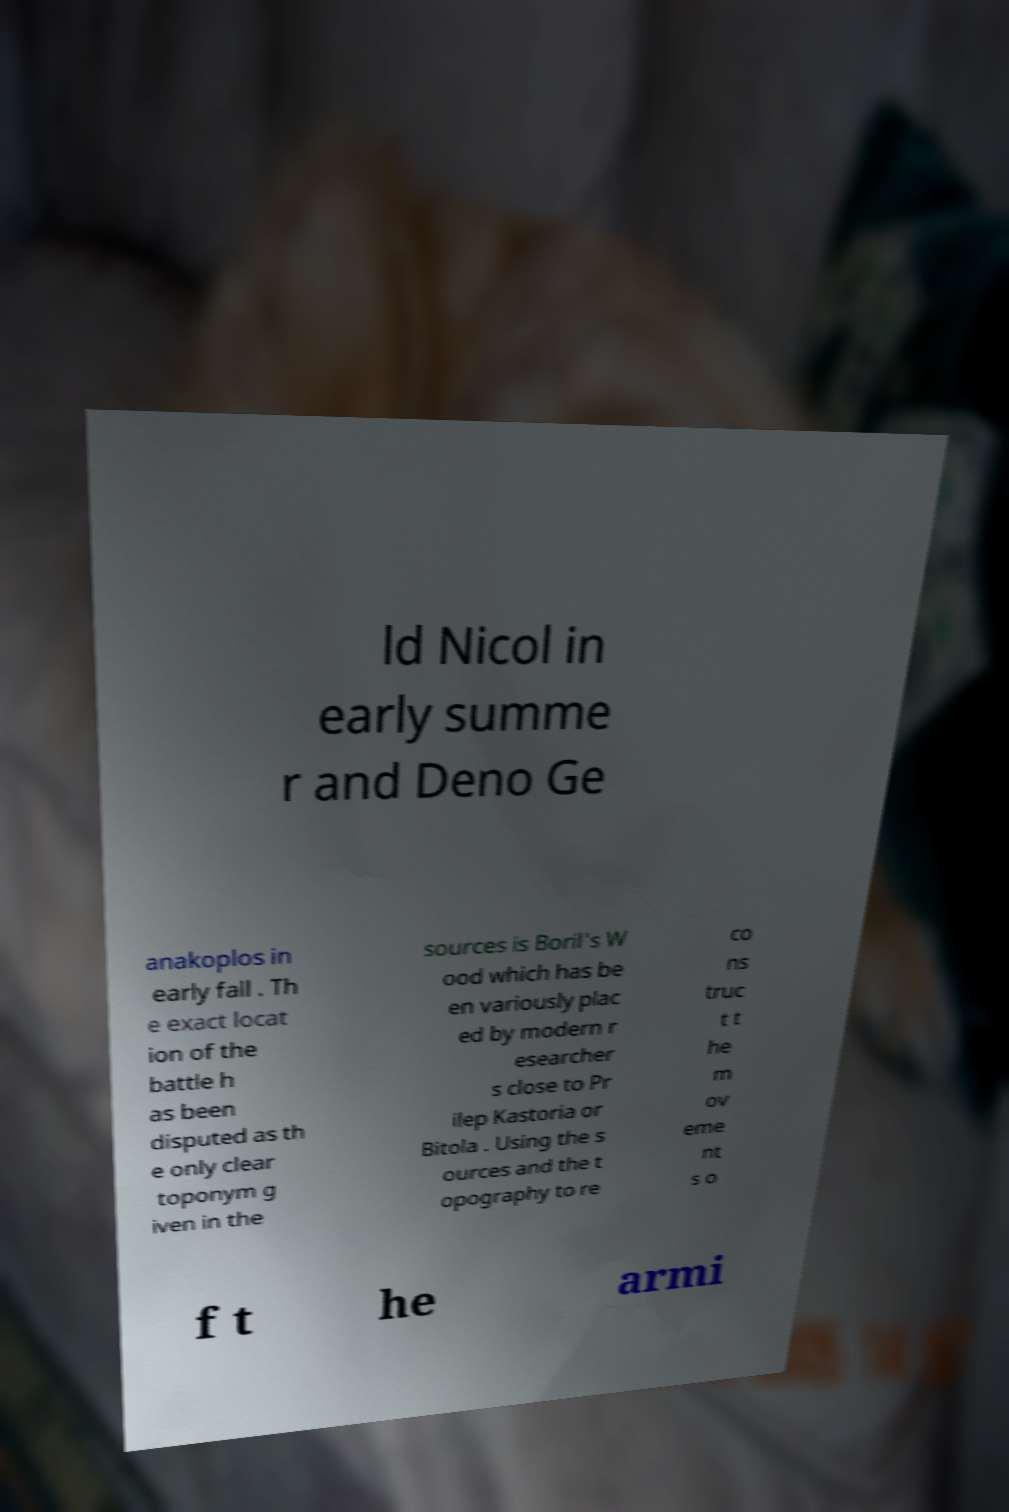Could you assist in decoding the text presented in this image and type it out clearly? ld Nicol in early summe r and Deno Ge anakoplos in early fall . Th e exact locat ion of the battle h as been disputed as th e only clear toponym g iven in the sources is Boril's W ood which has be en variously plac ed by modern r esearcher s close to Pr ilep Kastoria or Bitola . Using the s ources and the t opography to re co ns truc t t he m ov eme nt s o f t he armi 